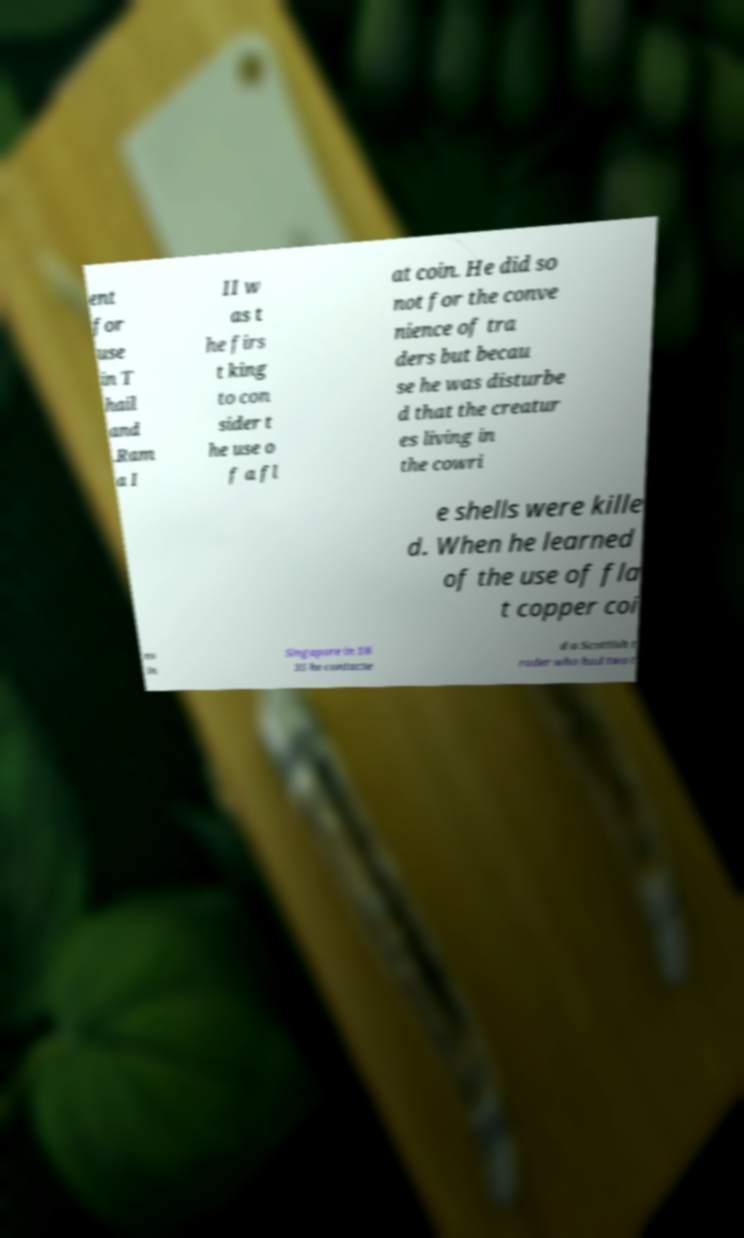Could you extract and type out the text from this image? ent for use in T hail and .Ram a I II w as t he firs t king to con sider t he use o f a fl at coin. He did so not for the conve nience of tra ders but becau se he was disturbe d that the creatur es living in the cowri e shells were kille d. When he learned of the use of fla t copper coi ns in Singapore in 18 35 he contacte d a Scottish t rader who had two t 